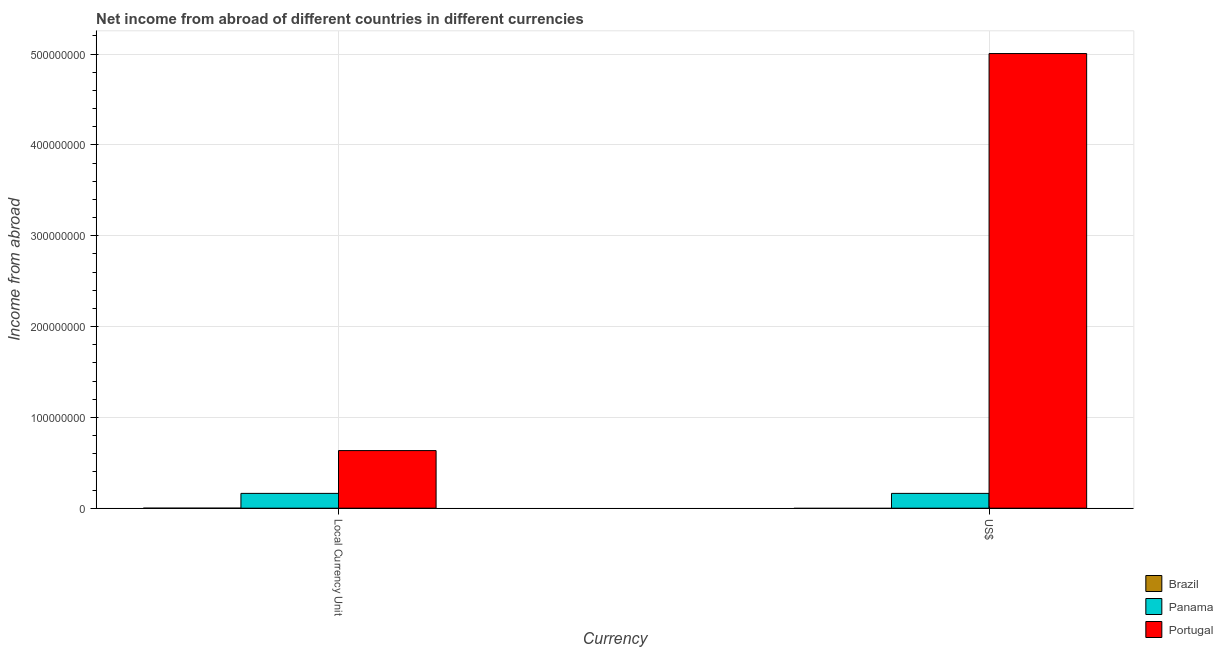How many different coloured bars are there?
Ensure brevity in your answer.  2. How many groups of bars are there?
Make the answer very short. 2. What is the label of the 1st group of bars from the left?
Offer a terse response. Local Currency Unit. What is the income from abroad in us$ in Portugal?
Offer a very short reply. 5.01e+08. Across all countries, what is the maximum income from abroad in constant 2005 us$?
Your answer should be very brief. 6.34e+07. Across all countries, what is the minimum income from abroad in constant 2005 us$?
Provide a succinct answer. 0. What is the total income from abroad in us$ in the graph?
Your response must be concise. 5.17e+08. What is the difference between the income from abroad in constant 2005 us$ in Panama and that in Portugal?
Give a very brief answer. -4.71e+07. What is the difference between the income from abroad in us$ in Brazil and the income from abroad in constant 2005 us$ in Portugal?
Your answer should be very brief. -6.34e+07. What is the average income from abroad in us$ per country?
Provide a short and direct response. 1.72e+08. What is the ratio of the income from abroad in constant 2005 us$ in Portugal to that in Panama?
Give a very brief answer. 3.89. Is the income from abroad in us$ in Portugal less than that in Panama?
Make the answer very short. No. How many bars are there?
Make the answer very short. 4. How many countries are there in the graph?
Keep it short and to the point. 3. How are the legend labels stacked?
Ensure brevity in your answer.  Vertical. What is the title of the graph?
Your response must be concise. Net income from abroad of different countries in different currencies. Does "Kuwait" appear as one of the legend labels in the graph?
Keep it short and to the point. No. What is the label or title of the X-axis?
Keep it short and to the point. Currency. What is the label or title of the Y-axis?
Make the answer very short. Income from abroad. What is the Income from abroad in Brazil in Local Currency Unit?
Provide a succinct answer. 0. What is the Income from abroad in Panama in Local Currency Unit?
Ensure brevity in your answer.  1.63e+07. What is the Income from abroad in Portugal in Local Currency Unit?
Give a very brief answer. 6.34e+07. What is the Income from abroad in Brazil in US$?
Offer a very short reply. 0. What is the Income from abroad of Panama in US$?
Give a very brief answer. 1.63e+07. What is the Income from abroad of Portugal in US$?
Keep it short and to the point. 5.01e+08. Across all Currency, what is the maximum Income from abroad in Panama?
Provide a succinct answer. 1.63e+07. Across all Currency, what is the maximum Income from abroad in Portugal?
Make the answer very short. 5.01e+08. Across all Currency, what is the minimum Income from abroad in Panama?
Offer a very short reply. 1.63e+07. Across all Currency, what is the minimum Income from abroad of Portugal?
Make the answer very short. 6.34e+07. What is the total Income from abroad in Brazil in the graph?
Your response must be concise. 0. What is the total Income from abroad in Panama in the graph?
Provide a short and direct response. 3.26e+07. What is the total Income from abroad in Portugal in the graph?
Provide a short and direct response. 5.64e+08. What is the difference between the Income from abroad in Panama in Local Currency Unit and that in US$?
Your answer should be compact. 0. What is the difference between the Income from abroad in Portugal in Local Currency Unit and that in US$?
Offer a very short reply. -4.37e+08. What is the difference between the Income from abroad in Panama in Local Currency Unit and the Income from abroad in Portugal in US$?
Give a very brief answer. -4.84e+08. What is the average Income from abroad in Panama per Currency?
Your answer should be very brief. 1.63e+07. What is the average Income from abroad of Portugal per Currency?
Provide a succinct answer. 2.82e+08. What is the difference between the Income from abroad in Panama and Income from abroad in Portugal in Local Currency Unit?
Your response must be concise. -4.71e+07. What is the difference between the Income from abroad of Panama and Income from abroad of Portugal in US$?
Offer a very short reply. -4.84e+08. What is the ratio of the Income from abroad of Panama in Local Currency Unit to that in US$?
Keep it short and to the point. 1. What is the ratio of the Income from abroad in Portugal in Local Currency Unit to that in US$?
Provide a succinct answer. 0.13. What is the difference between the highest and the second highest Income from abroad of Panama?
Your answer should be very brief. 0. What is the difference between the highest and the second highest Income from abroad in Portugal?
Your answer should be very brief. 4.37e+08. What is the difference between the highest and the lowest Income from abroad of Portugal?
Ensure brevity in your answer.  4.37e+08. 